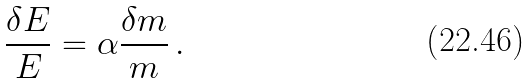Convert formula to latex. <formula><loc_0><loc_0><loc_500><loc_500>\frac { \delta E } { E } = \alpha \frac { \delta m } { m } \, .</formula> 